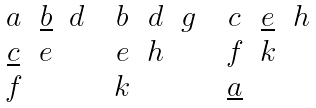<formula> <loc_0><loc_0><loc_500><loc_500>\begin{matrix} a & \underline { b } & d \\ \underline { c } & e & \\ f & & \end{matrix} \quad \begin{matrix} b & d & g \\ e & h & \\ k & & \end{matrix} \quad \begin{matrix} c & \underline { e } & h \\ f & k & \\ \underline { a } & & \end{matrix}</formula> 